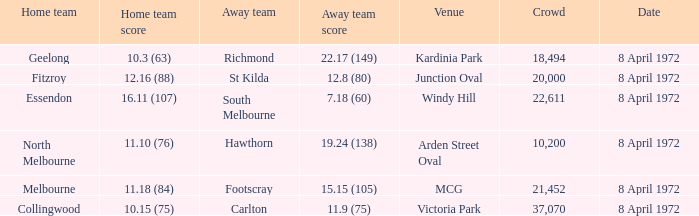Which Away team score has a Venue of kardinia park? 22.17 (149). 